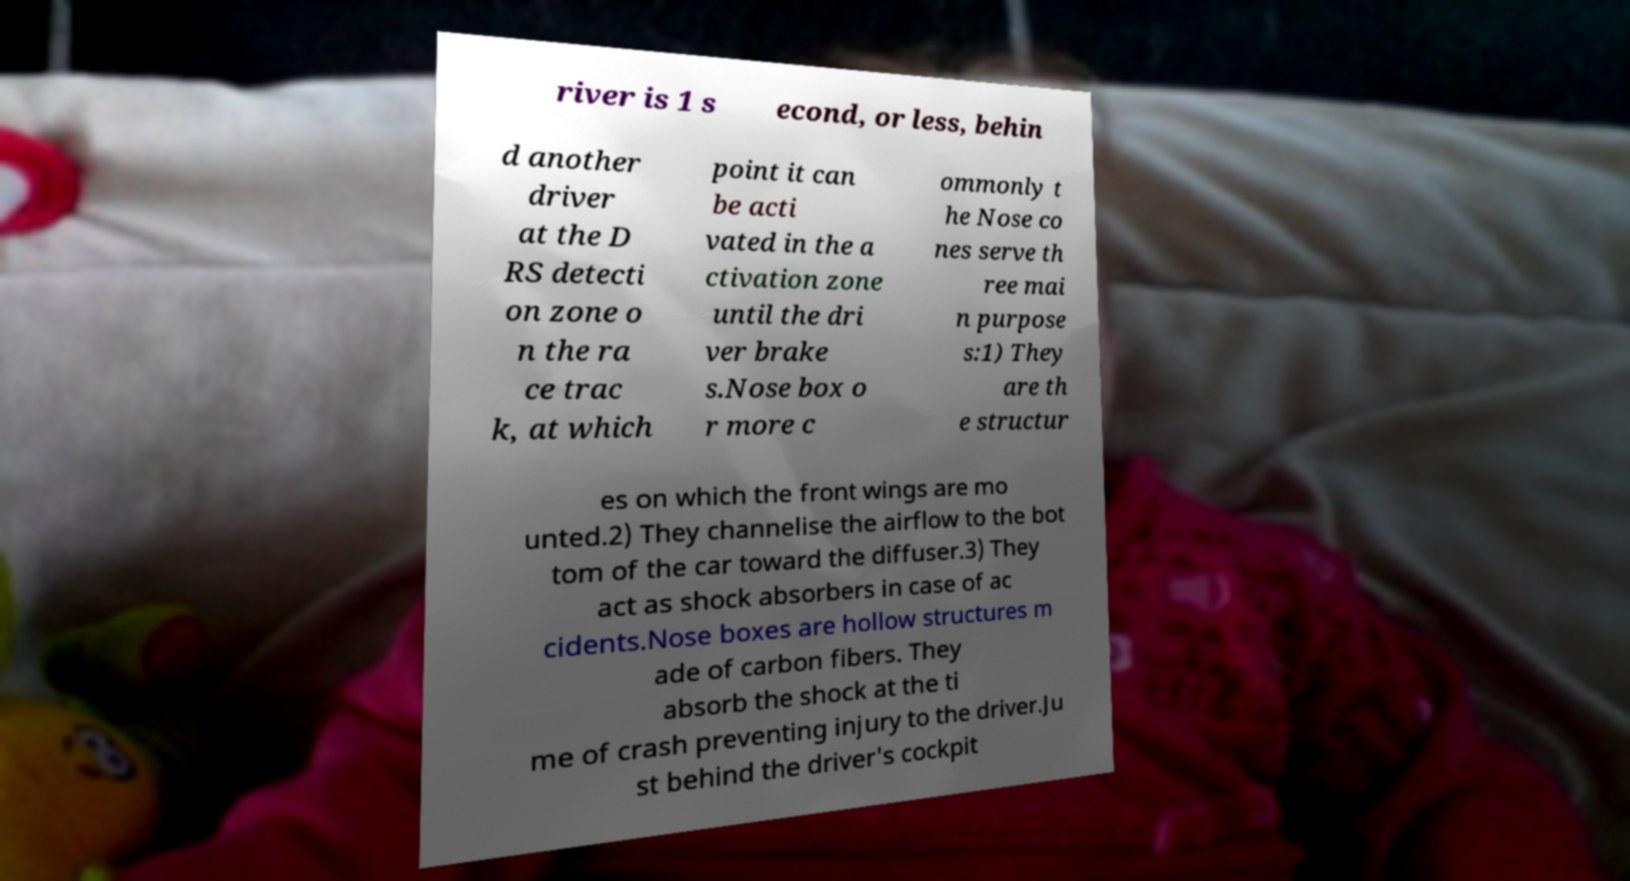Can you read and provide the text displayed in the image?This photo seems to have some interesting text. Can you extract and type it out for me? river is 1 s econd, or less, behin d another driver at the D RS detecti on zone o n the ra ce trac k, at which point it can be acti vated in the a ctivation zone until the dri ver brake s.Nose box o r more c ommonly t he Nose co nes serve th ree mai n purpose s:1) They are th e structur es on which the front wings are mo unted.2) They channelise the airflow to the bot tom of the car toward the diffuser.3) They act as shock absorbers in case of ac cidents.Nose boxes are hollow structures m ade of carbon fibers. They absorb the shock at the ti me of crash preventing injury to the driver.Ju st behind the driver's cockpit 